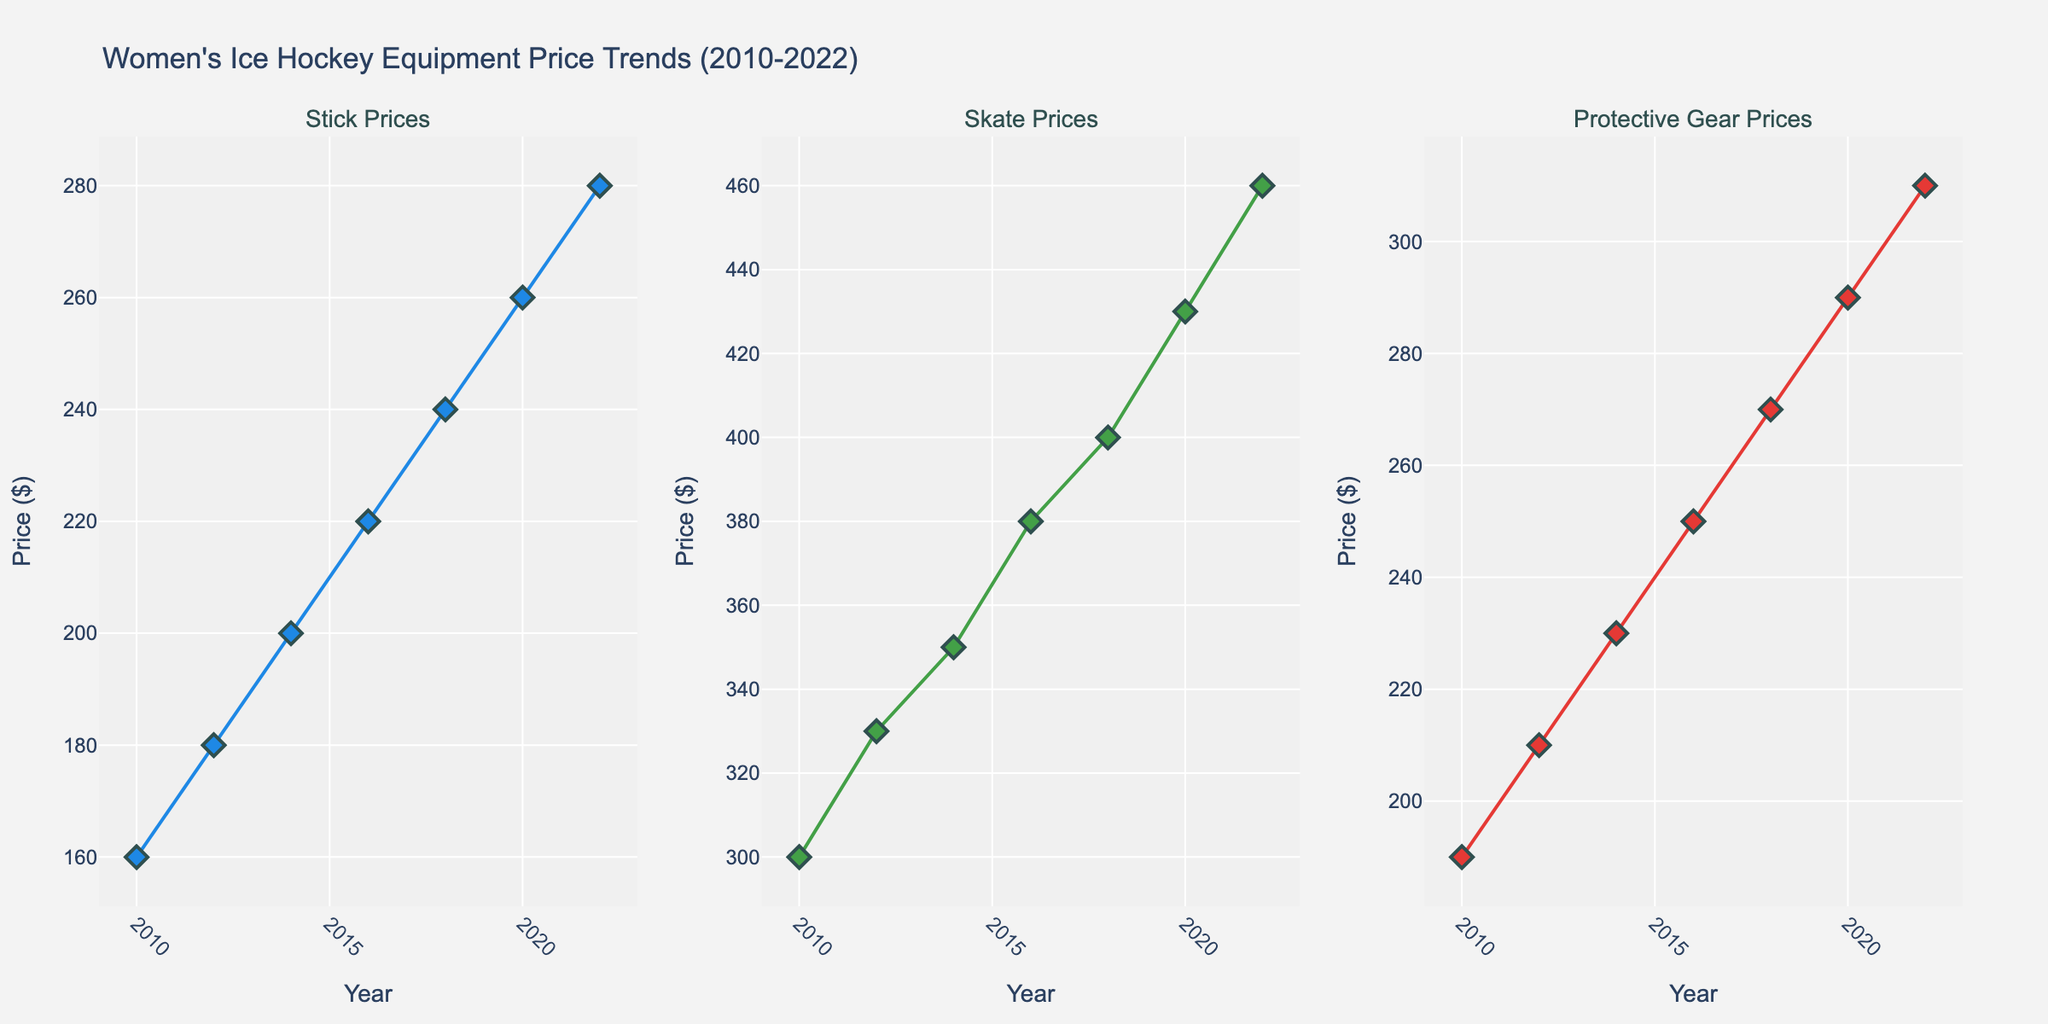How many different brands are represented in the protective gear category? By observing the data points for the "Protective Gear" subplot, there are brands labeled next to each of the marker points. Count the unique brand names.
Answer: 4 Which year shows the highest price for skates and which brand is it? Check the highest data point in the "Skate Prices" subplot. Note the year and the brand associated with that point.
Answer: 2022, Bauer What is the overall trend in stick prices from 2010 to 2022? Observe the scatter plot for stick prices, connect the price points from 2010 to 2022 and note the overall direction.
Answer: Increasing Between 2010 and 2018, what is the average price increase for protective gear? Find the price for protective gear in 2010 and 2018, then calculate the increase divided by the number of years. [(269.99 - 189.99) / (2018 - 2010)]
Answer: 10 USD/year Compare the prices of Bauer's sticks and skates in 2022. Which one is higher and by how much? Look at the prices of Bauer's stick and skates in the respective subplots for the year 2022. Subtract the stick price from the skate price.
Answer: Skates, 180 USD Which equipment shows the most consistent price trend across the years? By comparing the three subplots, identify which equipment's price points form the most linear or stable trend line.
Answer: Stick Which brand appears most frequently in the skate price subplot? Count the appearances of each brand in the "Skate Prices" subplot and determine the most frequent one.
Answer: Bauer What is the percentage increase in the price of CCM's protective gear from 2014 to 2020? Find the price of CCM protective gear in 2014 and 2020. Use the formula: [(new price - old price) / old price * 100]. [(289.99 - 229.99) / 229.99 * 100]
Answer: 26.09% In which year did Warrior offer products in both the stick and protective gear categories, and how much did they cost? Look at the price points labeled Warrior in both the "Stick Prices" and "Protective Gear Prices" subplots, then compare the years. Record the costs for the identified year.
Answer: 2014; Stick: 199.99 USD, Protective Gear: 229.99 USD Which year showed the largest price increase for skates from the previous recorded price? Identify the years with recorded prices for skates. Calculate the difference between consecutive years and identify the largest increase. [(2022 price - 2020 price)]
Answer: 2020 to 2022, 30 USD 